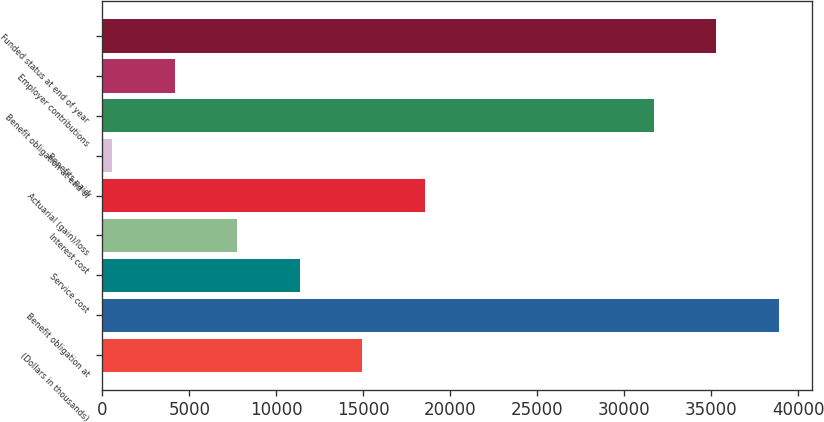<chart> <loc_0><loc_0><loc_500><loc_500><bar_chart><fcel>(Dollars in thousands)<fcel>Benefit obligation at<fcel>Service cost<fcel>Interest cost<fcel>Actuarial (gain)/loss<fcel>Benefits paid<fcel>Benefit obligation at end of<fcel>Employer contributions<fcel>Funded status at end of year<nl><fcel>14943.2<fcel>38874.6<fcel>11349.4<fcel>7755.6<fcel>18537<fcel>568<fcel>31687<fcel>4161.8<fcel>35280.8<nl></chart> 